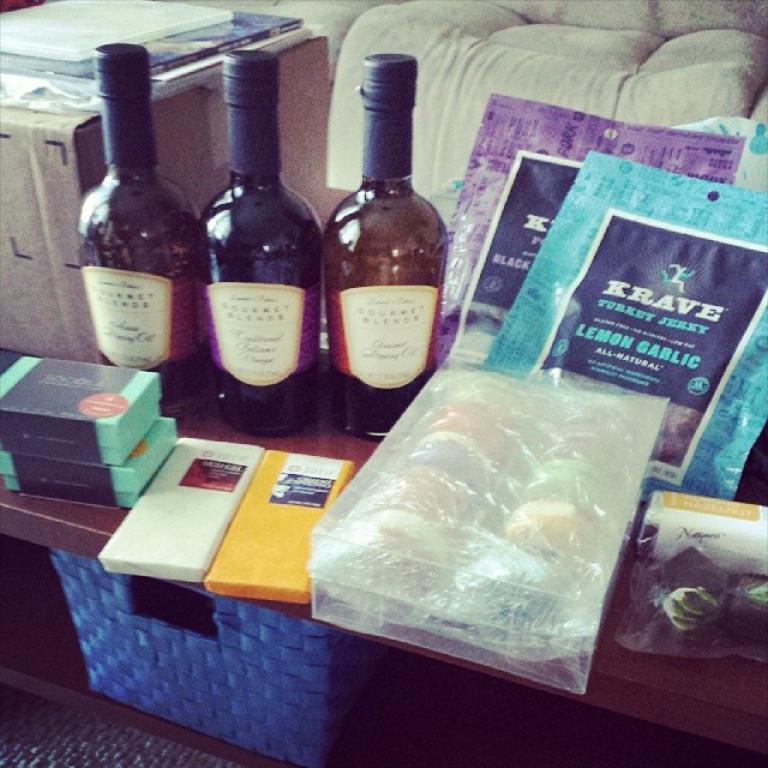<image>
Provide a brief description of the given image. An assortment include three bottles of wine and packs of Krave Turkey Jerky. 